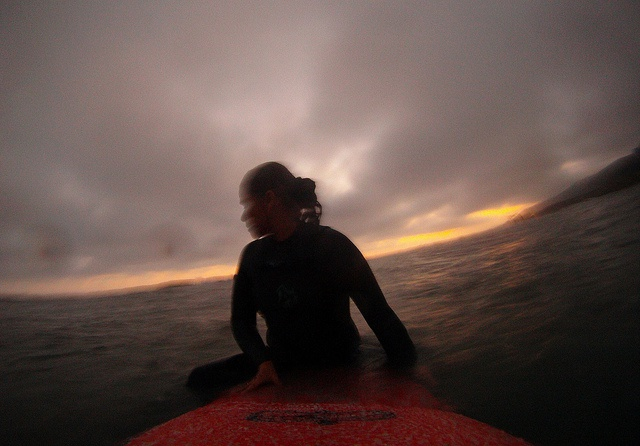Describe the objects in this image and their specific colors. I can see people in gray, black, maroon, brown, and darkgray tones and surfboard in black, maroon, and gray tones in this image. 